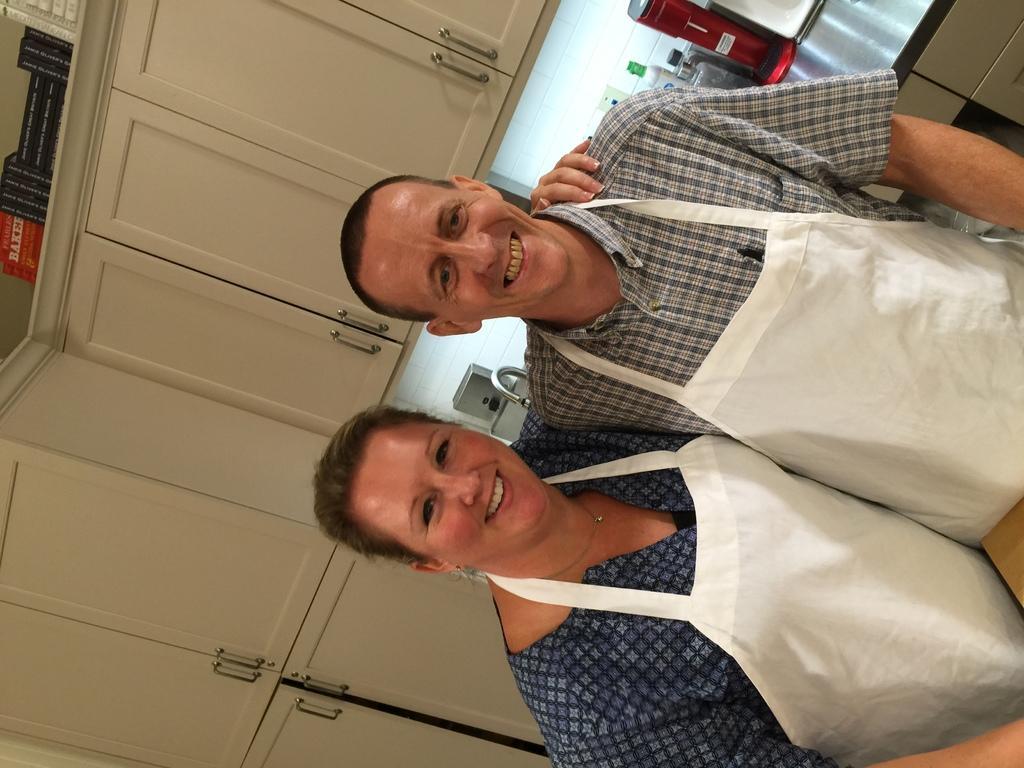Describe this image in one or two sentences. In the picture we can see man and woman standing together wearing chef suits and posing for a photograph and in the background there are some cupboards, some bottles and other things on surface. 